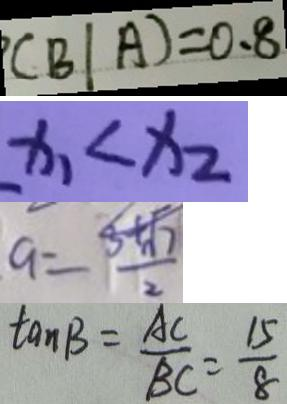<formula> <loc_0><loc_0><loc_500><loc_500>( B \vert A ) = 0 . 8 
 x _ { 1 } < x _ { 2 } 
 a = \frac { 3 + \sqrt { 7 } } { 2 } 
 \tan B = \frac { A C } { B C } = \frac { 1 5 } { 8 }</formula> 